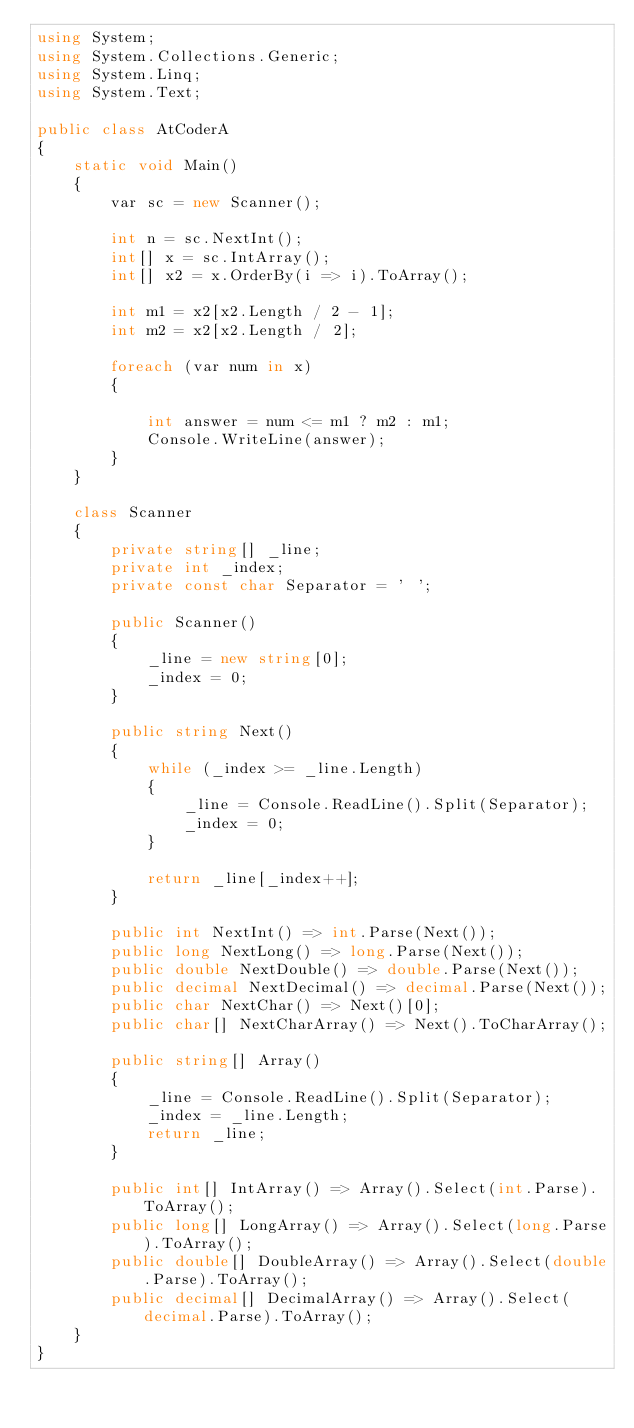Convert code to text. <code><loc_0><loc_0><loc_500><loc_500><_C#_>using System;
using System.Collections.Generic;
using System.Linq;
using System.Text;

public class AtCoderA
{
    static void Main()
    {
        var sc = new Scanner();

        int n = sc.NextInt();
        int[] x = sc.IntArray();
        int[] x2 = x.OrderBy(i => i).ToArray();

        int m1 = x2[x2.Length / 2 - 1];
        int m2 = x2[x2.Length / 2];

        foreach (var num in x)
        {

            int answer = num <= m1 ? m2 : m1;
            Console.WriteLine(answer);
        }
    }

    class Scanner
    {
        private string[] _line;
        private int _index;
        private const char Separator = ' ';

        public Scanner()
        {
            _line = new string[0];
            _index = 0;
        }

        public string Next()
        {
            while (_index >= _line.Length)
            {
                _line = Console.ReadLine().Split(Separator);
                _index = 0;
            }

            return _line[_index++];
        }

        public int NextInt() => int.Parse(Next());
        public long NextLong() => long.Parse(Next());
        public double NextDouble() => double.Parse(Next());
        public decimal NextDecimal() => decimal.Parse(Next());
        public char NextChar() => Next()[0];
        public char[] NextCharArray() => Next().ToCharArray();

        public string[] Array()
        {
            _line = Console.ReadLine().Split(Separator);
            _index = _line.Length;
            return _line;
        }

        public int[] IntArray() => Array().Select(int.Parse).ToArray();
        public long[] LongArray() => Array().Select(long.Parse).ToArray();
        public double[] DoubleArray() => Array().Select(double.Parse).ToArray();
        public decimal[] DecimalArray() => Array().Select(decimal.Parse).ToArray();
    }
}
</code> 